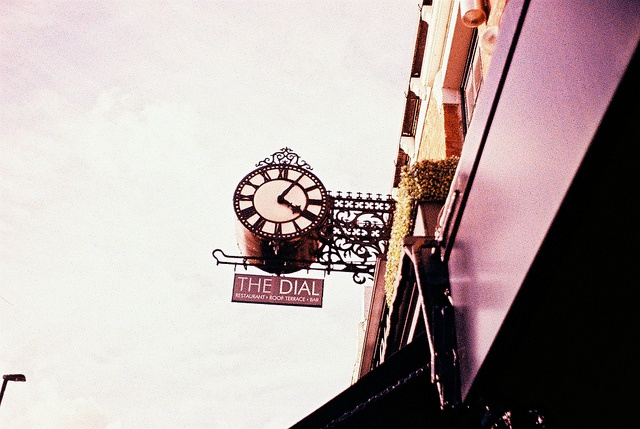Describe the objects in this image and their specific colors. I can see a clock in lavender, lightgray, black, maroon, and tan tones in this image. 